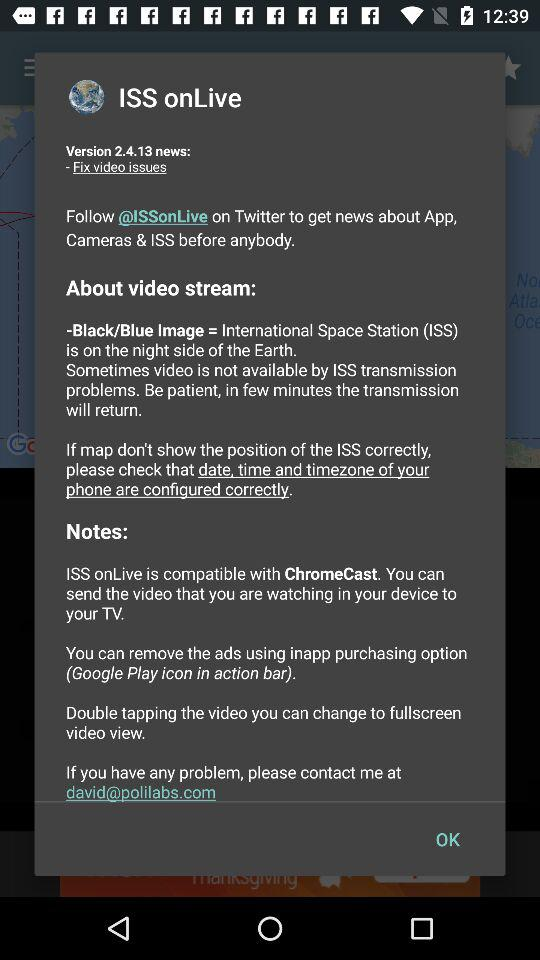What email ID is available for contact? The email ID that is available for contact is david@polilabs.com. 